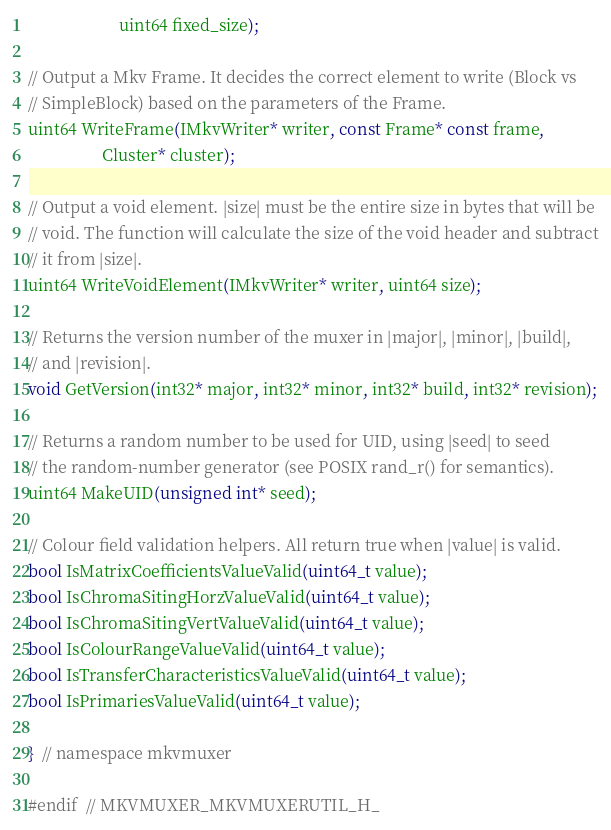<code> <loc_0><loc_0><loc_500><loc_500><_C_>                      uint64 fixed_size);

// Output a Mkv Frame. It decides the correct element to write (Block vs
// SimpleBlock) based on the parameters of the Frame.
uint64 WriteFrame(IMkvWriter* writer, const Frame* const frame,
                  Cluster* cluster);

// Output a void element. |size| must be the entire size in bytes that will be
// void. The function will calculate the size of the void header and subtract
// it from |size|.
uint64 WriteVoidElement(IMkvWriter* writer, uint64 size);

// Returns the version number of the muxer in |major|, |minor|, |build|,
// and |revision|.
void GetVersion(int32* major, int32* minor, int32* build, int32* revision);

// Returns a random number to be used for UID, using |seed| to seed
// the random-number generator (see POSIX rand_r() for semantics).
uint64 MakeUID(unsigned int* seed);

// Colour field validation helpers. All return true when |value| is valid.
bool IsMatrixCoefficientsValueValid(uint64_t value);
bool IsChromaSitingHorzValueValid(uint64_t value);
bool IsChromaSitingVertValueValid(uint64_t value);
bool IsColourRangeValueValid(uint64_t value);
bool IsTransferCharacteristicsValueValid(uint64_t value);
bool IsPrimariesValueValid(uint64_t value);

}  // namespace mkvmuxer

#endif  // MKVMUXER_MKVMUXERUTIL_H_
</code> 